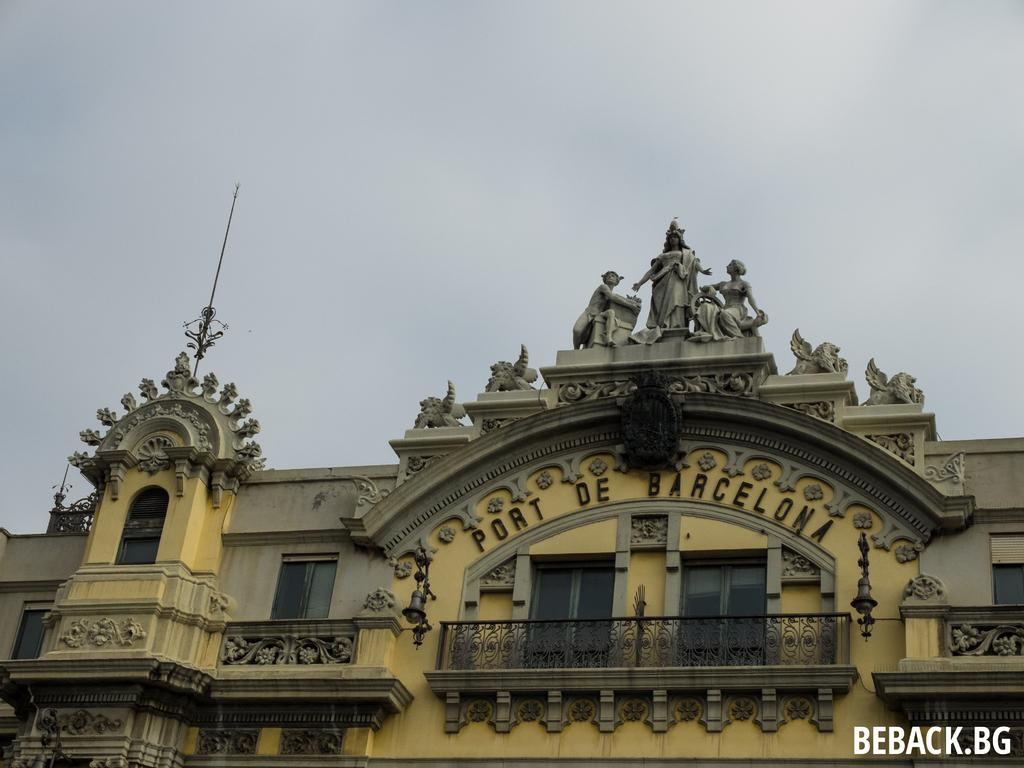<image>
Provide a brief description of the given image. Building called Port De Barcelona with statues on top. 